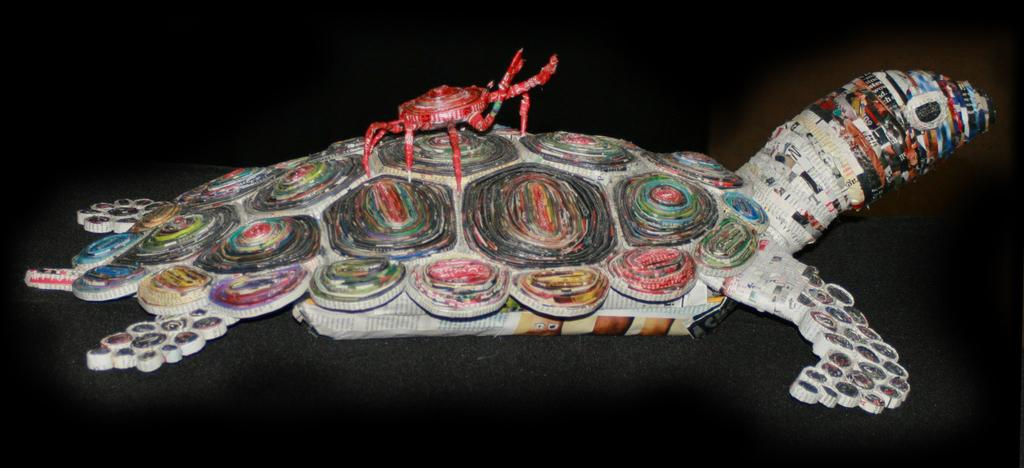What type of animals are crafted in the image? There is a crafted turtle and a crafted crab in the image. Where are the crafted animals located? Both the turtle and crab are on a surface in the image. What is the color of the background in the image? The background of the image is dark. What type of love is expressed between the men in the image? There are no men present in the image, and therefore no expression of love can be observed. How many fingers can be seen on the crafted turtle in the image? The crafted turtle does not have fingers, as it is not a human or an animal with fingers. 